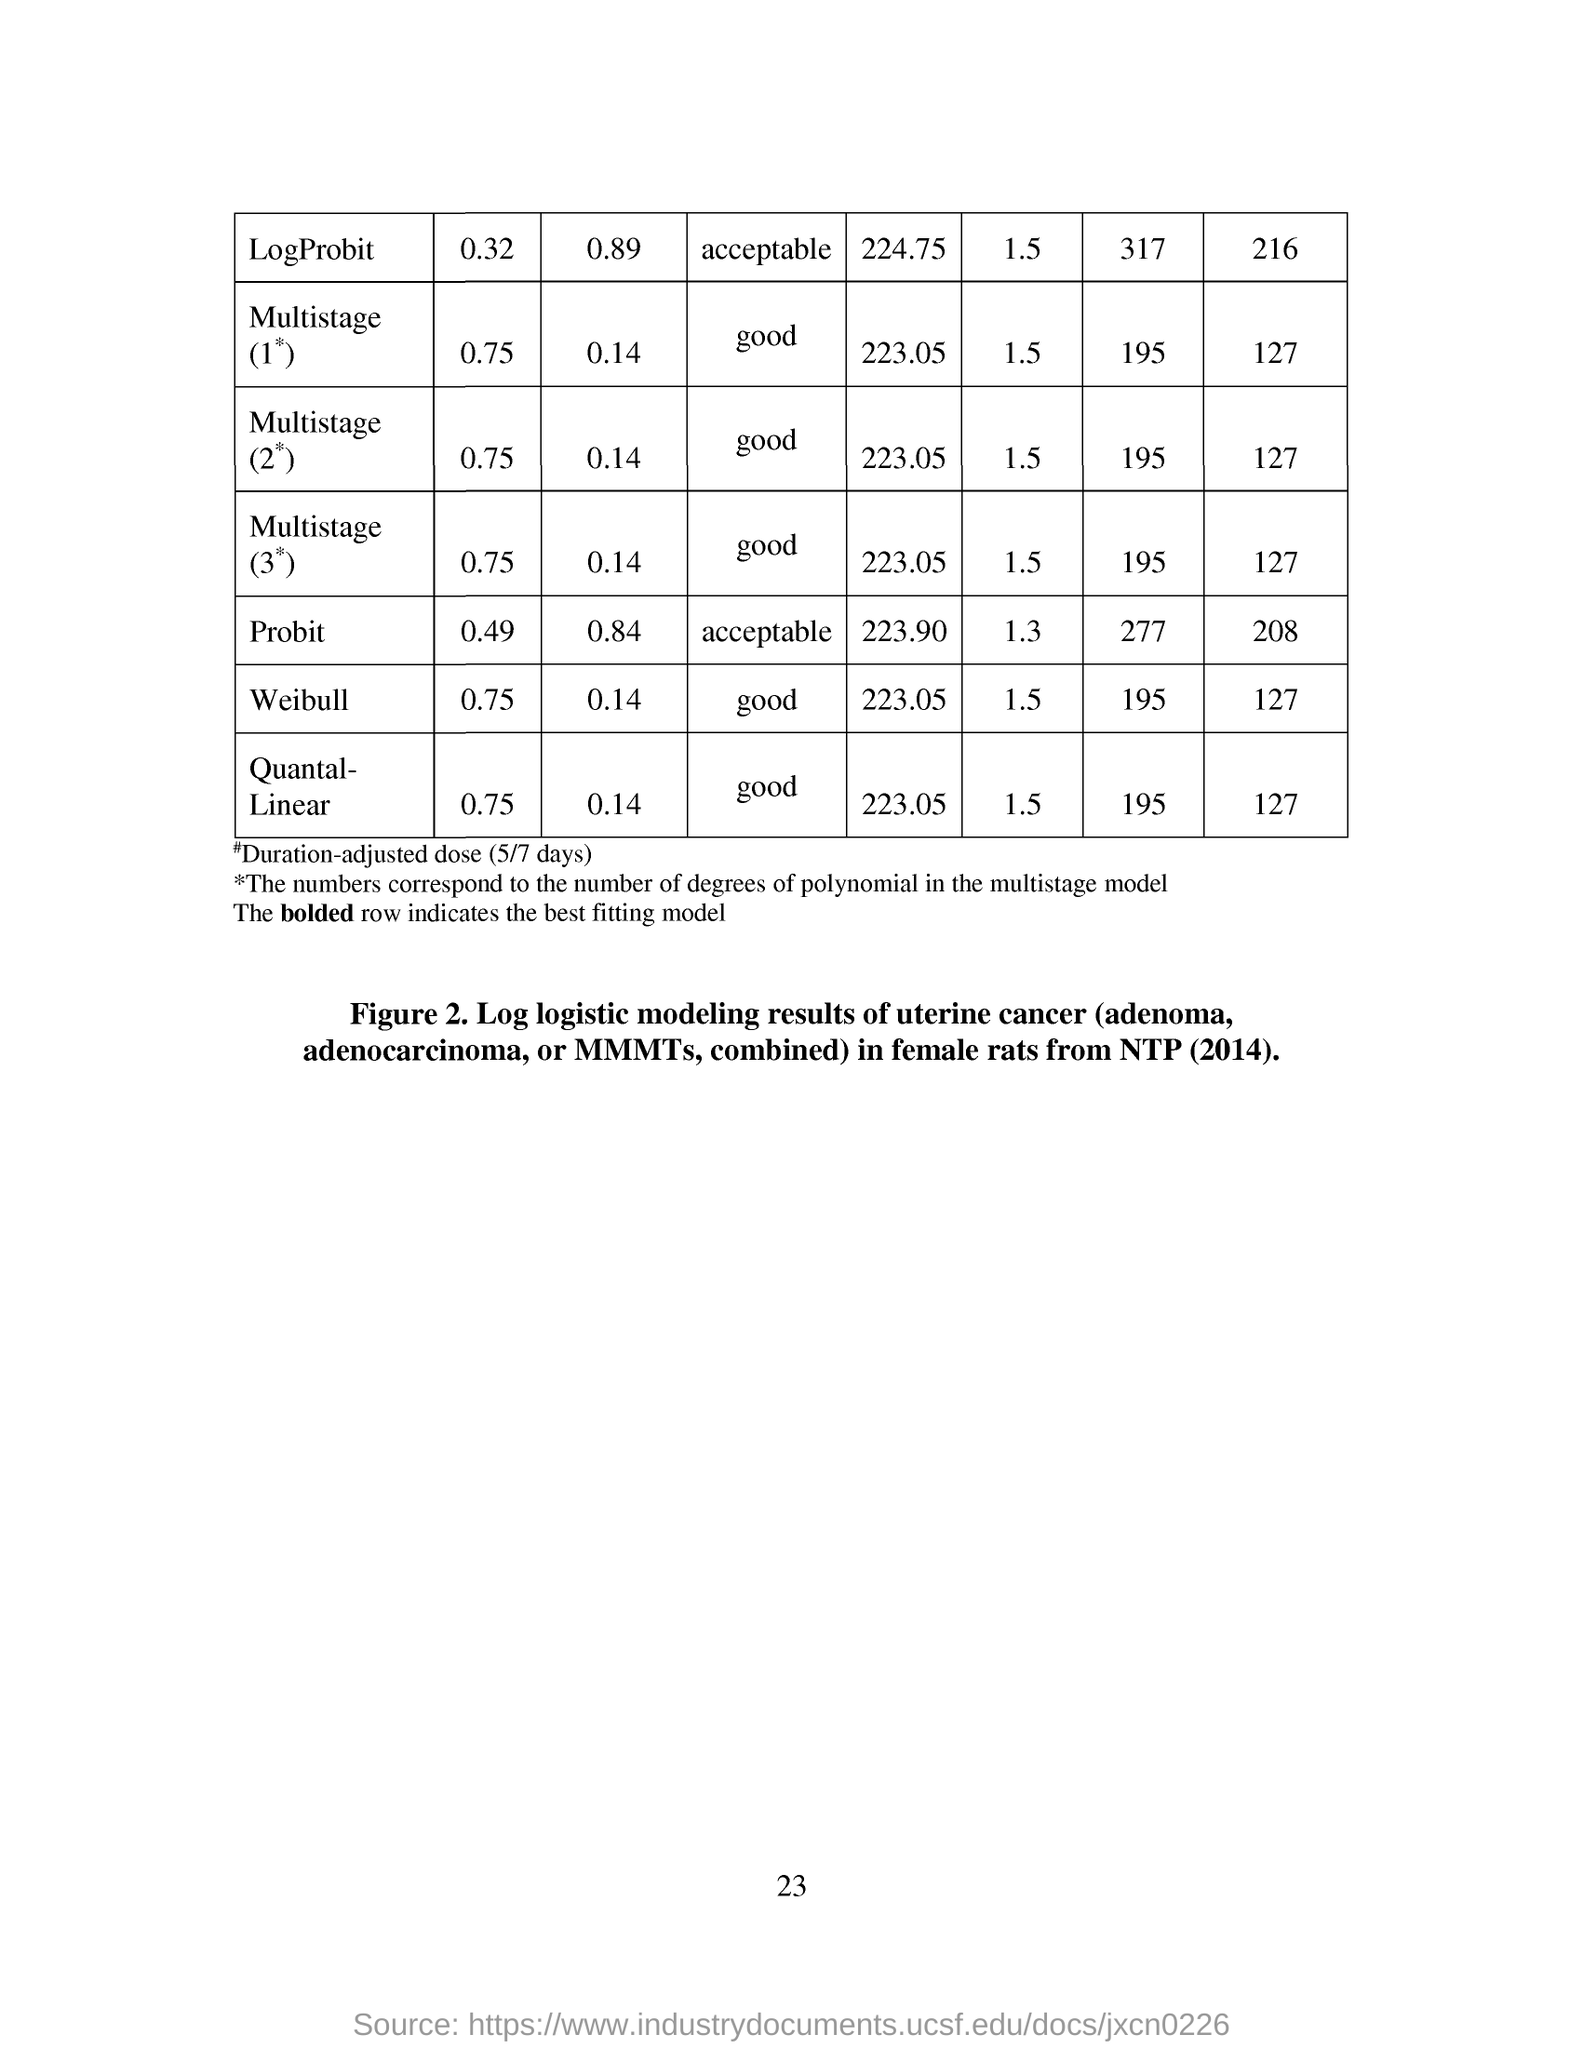What is the page no mentioned in this document?
Your response must be concise. 23. 